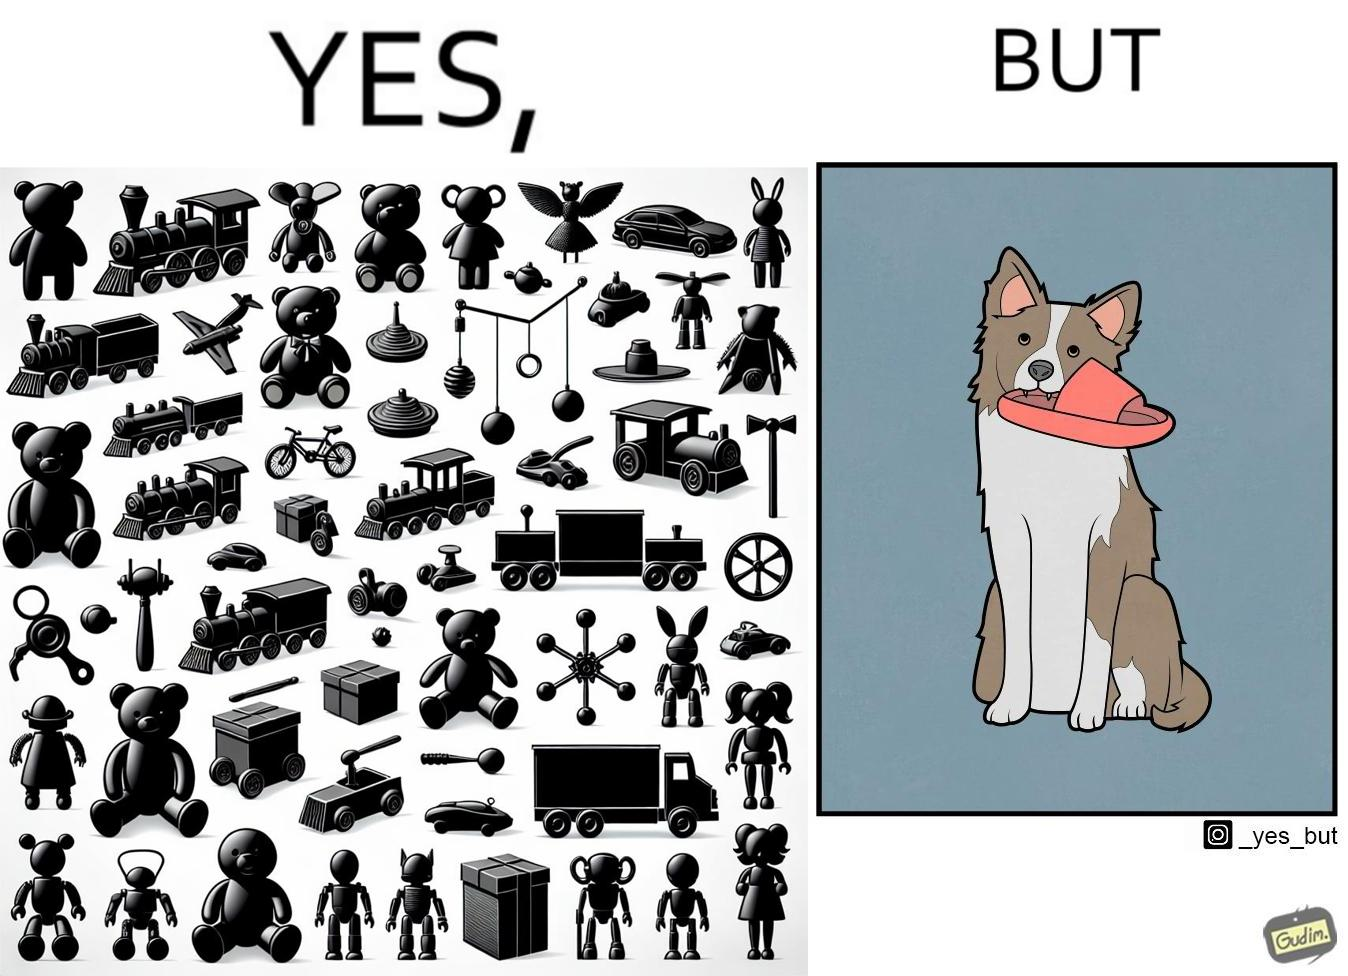Describe the content of this image. The image is ironical, as even though the dog owner has bought toys for the dog, the dog is playing with a slipper in its mouth. 